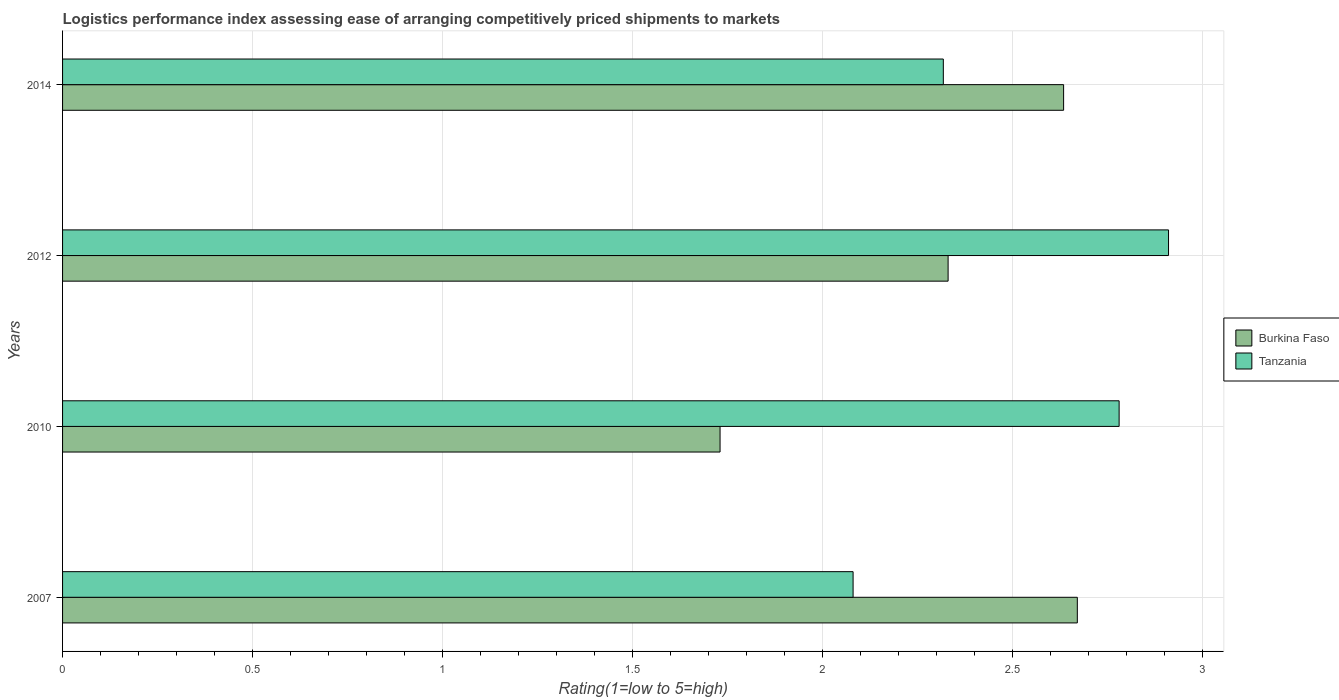How many different coloured bars are there?
Ensure brevity in your answer.  2. Are the number of bars on each tick of the Y-axis equal?
Give a very brief answer. Yes. How many bars are there on the 1st tick from the top?
Provide a succinct answer. 2. What is the label of the 3rd group of bars from the top?
Provide a short and direct response. 2010. What is the Logistic performance index in Tanzania in 2012?
Make the answer very short. 2.91. Across all years, what is the maximum Logistic performance index in Burkina Faso?
Provide a succinct answer. 2.67. Across all years, what is the minimum Logistic performance index in Tanzania?
Keep it short and to the point. 2.08. What is the total Logistic performance index in Burkina Faso in the graph?
Provide a short and direct response. 9.36. What is the difference between the Logistic performance index in Tanzania in 2012 and that in 2014?
Offer a terse response. 0.59. What is the difference between the Logistic performance index in Burkina Faso in 2010 and the Logistic performance index in Tanzania in 2007?
Your answer should be compact. -0.35. What is the average Logistic performance index in Burkina Faso per year?
Provide a short and direct response. 2.34. In the year 2012, what is the difference between the Logistic performance index in Tanzania and Logistic performance index in Burkina Faso?
Give a very brief answer. 0.58. What is the ratio of the Logistic performance index in Tanzania in 2010 to that in 2014?
Make the answer very short. 1.2. What is the difference between the highest and the second highest Logistic performance index in Burkina Faso?
Provide a short and direct response. 0.04. What is the difference between the highest and the lowest Logistic performance index in Tanzania?
Your answer should be very brief. 0.83. What does the 2nd bar from the top in 2007 represents?
Offer a terse response. Burkina Faso. What does the 1st bar from the bottom in 2010 represents?
Your answer should be compact. Burkina Faso. Are all the bars in the graph horizontal?
Give a very brief answer. Yes. How many years are there in the graph?
Provide a succinct answer. 4. Are the values on the major ticks of X-axis written in scientific E-notation?
Ensure brevity in your answer.  No. Does the graph contain any zero values?
Provide a short and direct response. No. Where does the legend appear in the graph?
Your answer should be compact. Center right. What is the title of the graph?
Your response must be concise. Logistics performance index assessing ease of arranging competitively priced shipments to markets. Does "France" appear as one of the legend labels in the graph?
Provide a short and direct response. No. What is the label or title of the X-axis?
Offer a very short reply. Rating(1=low to 5=high). What is the Rating(1=low to 5=high) in Burkina Faso in 2007?
Your answer should be very brief. 2.67. What is the Rating(1=low to 5=high) of Tanzania in 2007?
Make the answer very short. 2.08. What is the Rating(1=low to 5=high) in Burkina Faso in 2010?
Your answer should be compact. 1.73. What is the Rating(1=low to 5=high) of Tanzania in 2010?
Make the answer very short. 2.78. What is the Rating(1=low to 5=high) in Burkina Faso in 2012?
Provide a succinct answer. 2.33. What is the Rating(1=low to 5=high) of Tanzania in 2012?
Ensure brevity in your answer.  2.91. What is the Rating(1=low to 5=high) in Burkina Faso in 2014?
Make the answer very short. 2.63. What is the Rating(1=low to 5=high) of Tanzania in 2014?
Give a very brief answer. 2.32. Across all years, what is the maximum Rating(1=low to 5=high) in Burkina Faso?
Keep it short and to the point. 2.67. Across all years, what is the maximum Rating(1=low to 5=high) of Tanzania?
Offer a terse response. 2.91. Across all years, what is the minimum Rating(1=low to 5=high) in Burkina Faso?
Keep it short and to the point. 1.73. Across all years, what is the minimum Rating(1=low to 5=high) in Tanzania?
Offer a terse response. 2.08. What is the total Rating(1=low to 5=high) in Burkina Faso in the graph?
Offer a very short reply. 9.36. What is the total Rating(1=low to 5=high) in Tanzania in the graph?
Provide a succinct answer. 10.09. What is the difference between the Rating(1=low to 5=high) in Tanzania in 2007 and that in 2010?
Offer a very short reply. -0.7. What is the difference between the Rating(1=low to 5=high) of Burkina Faso in 2007 and that in 2012?
Keep it short and to the point. 0.34. What is the difference between the Rating(1=low to 5=high) in Tanzania in 2007 and that in 2012?
Your answer should be compact. -0.83. What is the difference between the Rating(1=low to 5=high) of Burkina Faso in 2007 and that in 2014?
Keep it short and to the point. 0.04. What is the difference between the Rating(1=low to 5=high) in Tanzania in 2007 and that in 2014?
Your answer should be very brief. -0.24. What is the difference between the Rating(1=low to 5=high) of Burkina Faso in 2010 and that in 2012?
Your answer should be compact. -0.6. What is the difference between the Rating(1=low to 5=high) in Tanzania in 2010 and that in 2012?
Keep it short and to the point. -0.13. What is the difference between the Rating(1=low to 5=high) in Burkina Faso in 2010 and that in 2014?
Ensure brevity in your answer.  -0.9. What is the difference between the Rating(1=low to 5=high) of Tanzania in 2010 and that in 2014?
Keep it short and to the point. 0.46. What is the difference between the Rating(1=low to 5=high) of Burkina Faso in 2012 and that in 2014?
Your answer should be very brief. -0.3. What is the difference between the Rating(1=low to 5=high) of Tanzania in 2012 and that in 2014?
Provide a succinct answer. 0.59. What is the difference between the Rating(1=low to 5=high) of Burkina Faso in 2007 and the Rating(1=low to 5=high) of Tanzania in 2010?
Provide a succinct answer. -0.11. What is the difference between the Rating(1=low to 5=high) in Burkina Faso in 2007 and the Rating(1=low to 5=high) in Tanzania in 2012?
Make the answer very short. -0.24. What is the difference between the Rating(1=low to 5=high) of Burkina Faso in 2007 and the Rating(1=low to 5=high) of Tanzania in 2014?
Your answer should be very brief. 0.35. What is the difference between the Rating(1=low to 5=high) of Burkina Faso in 2010 and the Rating(1=low to 5=high) of Tanzania in 2012?
Provide a succinct answer. -1.18. What is the difference between the Rating(1=low to 5=high) in Burkina Faso in 2010 and the Rating(1=low to 5=high) in Tanzania in 2014?
Give a very brief answer. -0.59. What is the difference between the Rating(1=low to 5=high) of Burkina Faso in 2012 and the Rating(1=low to 5=high) of Tanzania in 2014?
Ensure brevity in your answer.  0.01. What is the average Rating(1=low to 5=high) in Burkina Faso per year?
Give a very brief answer. 2.34. What is the average Rating(1=low to 5=high) of Tanzania per year?
Your answer should be very brief. 2.52. In the year 2007, what is the difference between the Rating(1=low to 5=high) in Burkina Faso and Rating(1=low to 5=high) in Tanzania?
Provide a short and direct response. 0.59. In the year 2010, what is the difference between the Rating(1=low to 5=high) in Burkina Faso and Rating(1=low to 5=high) in Tanzania?
Offer a very short reply. -1.05. In the year 2012, what is the difference between the Rating(1=low to 5=high) of Burkina Faso and Rating(1=low to 5=high) of Tanzania?
Make the answer very short. -0.58. In the year 2014, what is the difference between the Rating(1=low to 5=high) in Burkina Faso and Rating(1=low to 5=high) in Tanzania?
Make the answer very short. 0.32. What is the ratio of the Rating(1=low to 5=high) of Burkina Faso in 2007 to that in 2010?
Give a very brief answer. 1.54. What is the ratio of the Rating(1=low to 5=high) in Tanzania in 2007 to that in 2010?
Provide a succinct answer. 0.75. What is the ratio of the Rating(1=low to 5=high) of Burkina Faso in 2007 to that in 2012?
Provide a short and direct response. 1.15. What is the ratio of the Rating(1=low to 5=high) in Tanzania in 2007 to that in 2012?
Your answer should be very brief. 0.71. What is the ratio of the Rating(1=low to 5=high) of Burkina Faso in 2007 to that in 2014?
Your answer should be compact. 1.01. What is the ratio of the Rating(1=low to 5=high) of Tanzania in 2007 to that in 2014?
Offer a terse response. 0.9. What is the ratio of the Rating(1=low to 5=high) of Burkina Faso in 2010 to that in 2012?
Provide a succinct answer. 0.74. What is the ratio of the Rating(1=low to 5=high) of Tanzania in 2010 to that in 2012?
Offer a terse response. 0.96. What is the ratio of the Rating(1=low to 5=high) of Burkina Faso in 2010 to that in 2014?
Ensure brevity in your answer.  0.66. What is the ratio of the Rating(1=low to 5=high) of Tanzania in 2010 to that in 2014?
Your response must be concise. 1.2. What is the ratio of the Rating(1=low to 5=high) in Burkina Faso in 2012 to that in 2014?
Offer a terse response. 0.88. What is the ratio of the Rating(1=low to 5=high) in Tanzania in 2012 to that in 2014?
Provide a succinct answer. 1.26. What is the difference between the highest and the second highest Rating(1=low to 5=high) of Burkina Faso?
Provide a short and direct response. 0.04. What is the difference between the highest and the second highest Rating(1=low to 5=high) in Tanzania?
Provide a succinct answer. 0.13. What is the difference between the highest and the lowest Rating(1=low to 5=high) of Tanzania?
Your response must be concise. 0.83. 